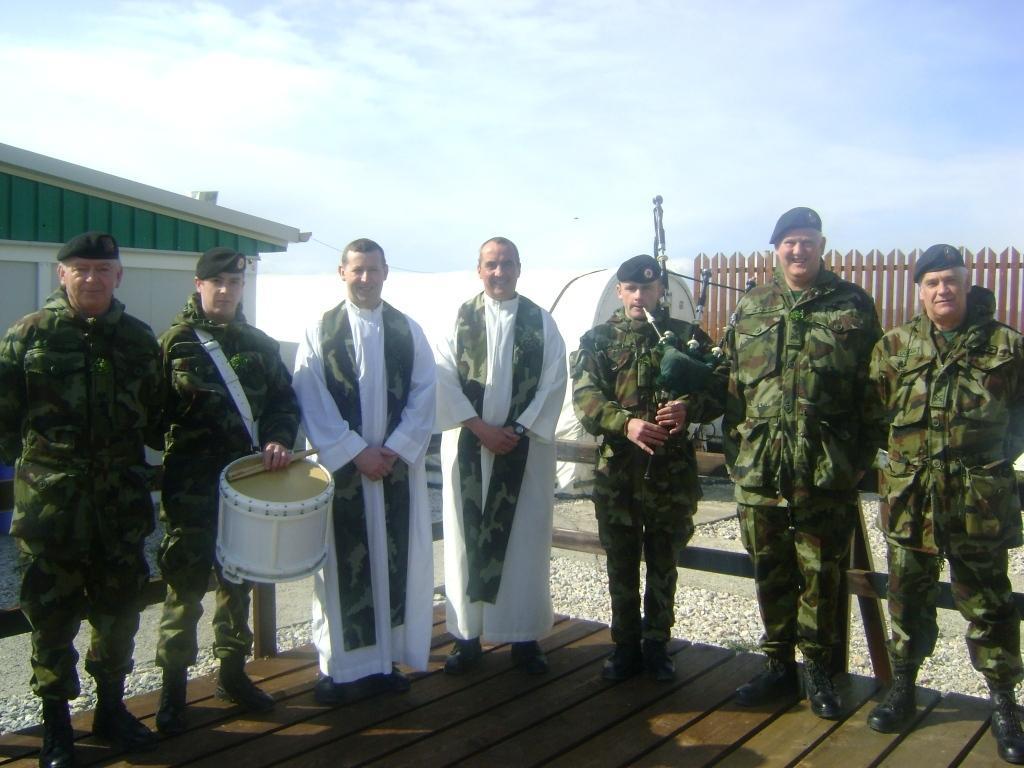Can you describe this image briefly? The picture is taken outside a building. In the foreground of the picture there are seven men standing. On the left there is a man holding drums. In the center there is a man playing pipes. On the right there is railing. On the left there is a building. In the center of the background there is a tent. Sky is clear and it is sunny. 